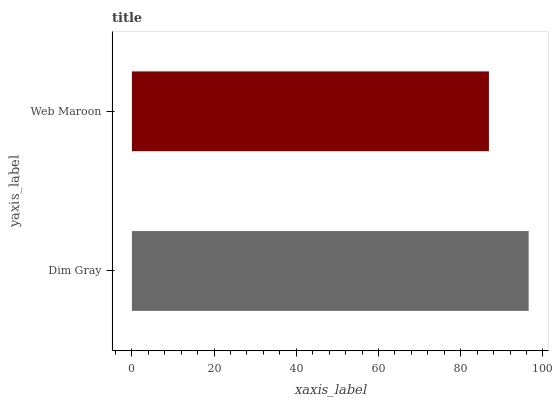Is Web Maroon the minimum?
Answer yes or no. Yes. Is Dim Gray the maximum?
Answer yes or no. Yes. Is Web Maroon the maximum?
Answer yes or no. No. Is Dim Gray greater than Web Maroon?
Answer yes or no. Yes. Is Web Maroon less than Dim Gray?
Answer yes or no. Yes. Is Web Maroon greater than Dim Gray?
Answer yes or no. No. Is Dim Gray less than Web Maroon?
Answer yes or no. No. Is Dim Gray the high median?
Answer yes or no. Yes. Is Web Maroon the low median?
Answer yes or no. Yes. Is Web Maroon the high median?
Answer yes or no. No. Is Dim Gray the low median?
Answer yes or no. No. 